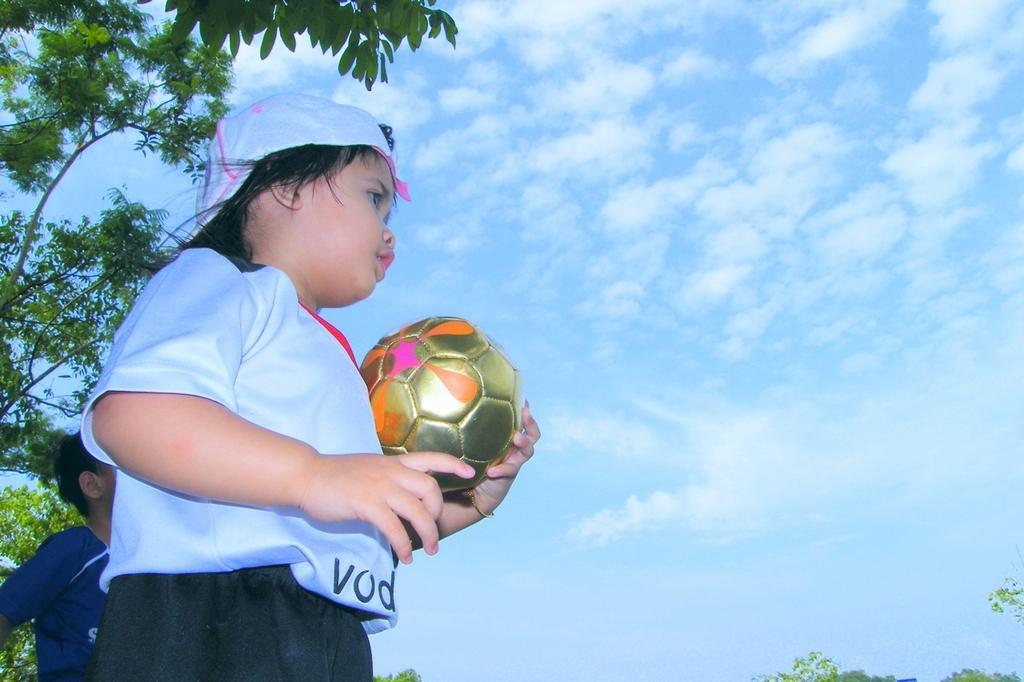Can you describe this image briefly? Here we can see a child standing and holding a ball in his hands, and at back a person is standing, and here is the tree, and the sky is cloudy. 